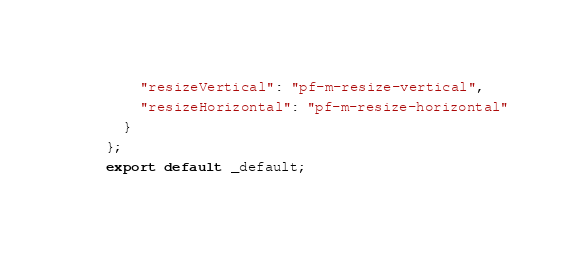Convert code to text. <code><loc_0><loc_0><loc_500><loc_500><_TypeScript_>    "resizeVertical": "pf-m-resize-vertical",
    "resizeHorizontal": "pf-m-resize-horizontal"
  }
};
export default _default;</code> 